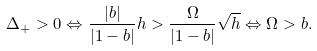<formula> <loc_0><loc_0><loc_500><loc_500>\Delta _ { + } > 0 \Leftrightarrow \frac { | b | } { | 1 - b | } h > \frac { \Omega } { | 1 - b | } \sqrt { h } \Leftrightarrow \Omega > b .</formula> 